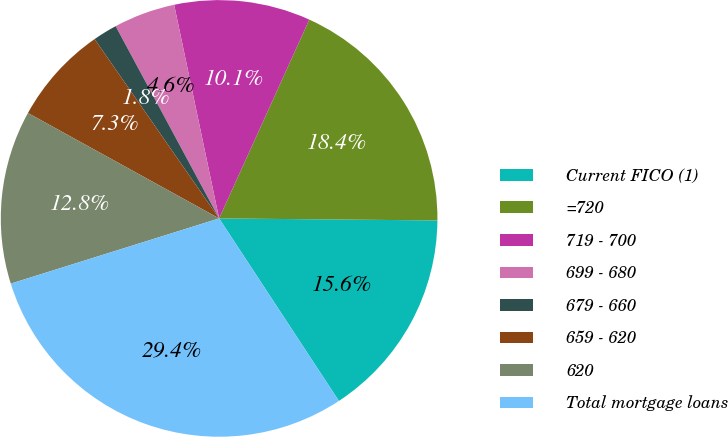<chart> <loc_0><loc_0><loc_500><loc_500><pie_chart><fcel>Current FICO (1)<fcel>=720<fcel>719 - 700<fcel>699 - 680<fcel>679 - 660<fcel>659 - 620<fcel>620<fcel>Total mortgage loans<nl><fcel>15.61%<fcel>18.37%<fcel>10.08%<fcel>4.56%<fcel>1.8%<fcel>7.32%<fcel>12.85%<fcel>29.42%<nl></chart> 